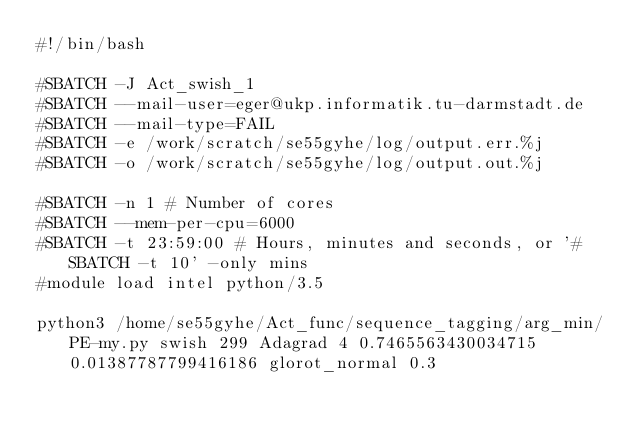Convert code to text. <code><loc_0><loc_0><loc_500><loc_500><_Bash_>#!/bin/bash
 
#SBATCH -J Act_swish_1
#SBATCH --mail-user=eger@ukp.informatik.tu-darmstadt.de
#SBATCH --mail-type=FAIL
#SBATCH -e /work/scratch/se55gyhe/log/output.err.%j
#SBATCH -o /work/scratch/se55gyhe/log/output.out.%j

#SBATCH -n 1 # Number of cores
#SBATCH --mem-per-cpu=6000
#SBATCH -t 23:59:00 # Hours, minutes and seconds, or '#SBATCH -t 10' -only mins
#module load intel python/3.5

python3 /home/se55gyhe/Act_func/sequence_tagging/arg_min/PE-my.py swish 299 Adagrad 4 0.7465563430034715 0.01387787799416186 glorot_normal 0.3

</code> 